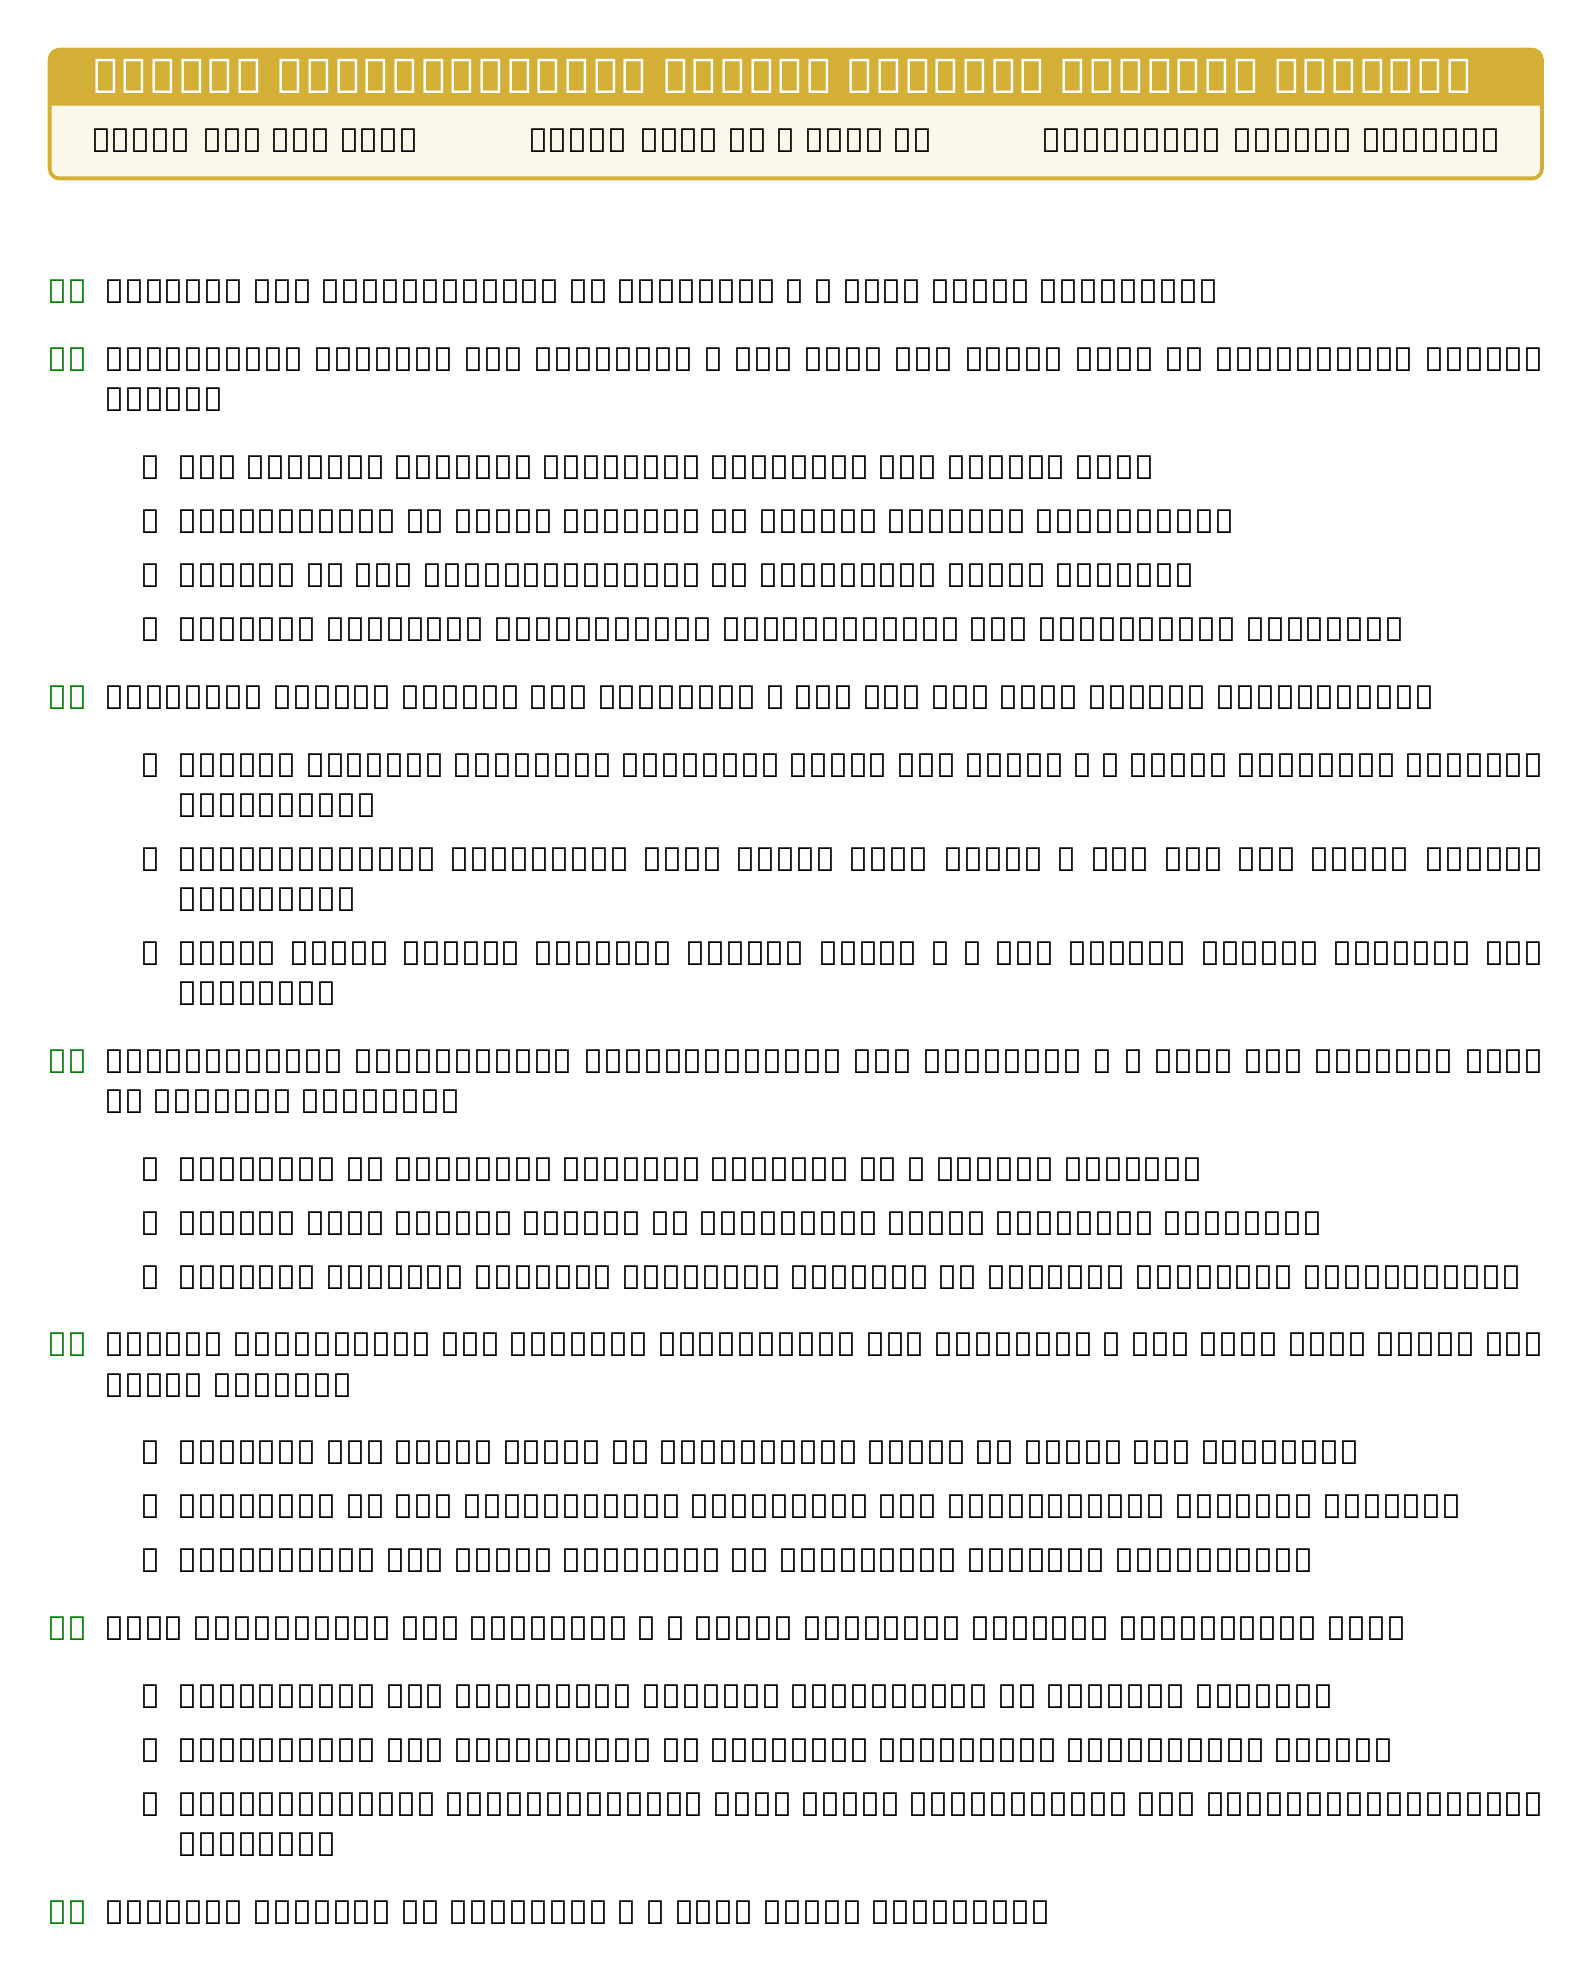What is the date of the meeting? The date of the meeting is provided in the document as May 15, 2023.
Answer: May 15, 2023 Who is the presenter for Curriculum Updates? The document lists Daw Khin Myo Chit as the presenter for the Curriculum Updates section.
Answer: Daw Khin Myo Chit How long is the discussion for Upcoming School Events? The document specifies that the duration of Upcoming School Events is 20 minutes.
Answer: 20 minutes What event is scheduled for June 10, 2023? The document indicates the Annual Myanmar Cultural Festival is on June 10, 2023.
Answer: Annual Myanmar Cultural Festival What is one of the professional development opportunities listed? The document includes a workshop on teaching Myanmar history in a global context as one of the opportunities.
Answer: Workshop on teaching Myanmar history in a global context How many minutes are allocated for the Open Discussion? The duration allocated for Open Discussion is mentioned in the document as 20 minutes.
Answer: 20 minutes Who coordinates the International Education Fair? The document states that Daw Zin Mar Aung is the coordinator for the International Education Fair.
Answer: Daw Zin Mar Aung What is the main topic of the Budget Allocation for History Department? The document discusses funding for field trips to historical sites in Bagan and Mandalay as a main topic.
Answer: Funding for field trips to historical sites in Bagan and Mandalay 